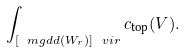Convert formula to latex. <formula><loc_0><loc_0><loc_500><loc_500>\int _ { [ \ m g d d ( W _ { r } ) ] \ v i r } c _ { \text {top} } ( V ) .</formula> 